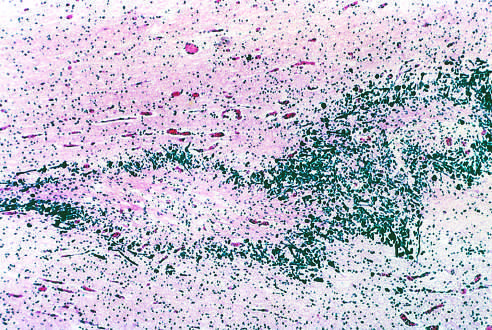what does this specimen from a patient with periventricular leukomalacia contain?
Answer the question using a single word or phrase. A central focus of white matter necrosis 